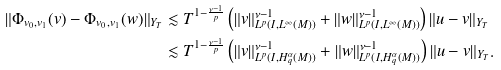Convert formula to latex. <formula><loc_0><loc_0><loc_500><loc_500>\| \Phi _ { v _ { 0 } , v _ { 1 } } ( v ) - \Phi _ { v _ { 0 } , v _ { 1 } } ( w ) \| _ { Y _ { T } } & \lesssim T ^ { 1 - \frac { \nu - 1 } { p } } \left ( \| v \| ^ { \nu - 1 } _ { L ^ { p } ( I , L ^ { \infty } ( M ) ) } + \| w \| ^ { \nu - 1 } _ { L ^ { p } ( I , L ^ { \infty } ( M ) ) } \right ) \| u - v \| _ { Y _ { T } } \\ & \lesssim T ^ { 1 - \frac { \nu - 1 } { p } } \left ( \| v \| ^ { \nu - 1 } _ { L ^ { p } ( I , H ^ { \alpha } _ { q } ( M ) ) } + \| w \| ^ { \nu - 1 } _ { L ^ { p } ( I , H ^ { \alpha } _ { q } ( M ) ) } \right ) \| u - v \| _ { Y _ { T } } .</formula> 